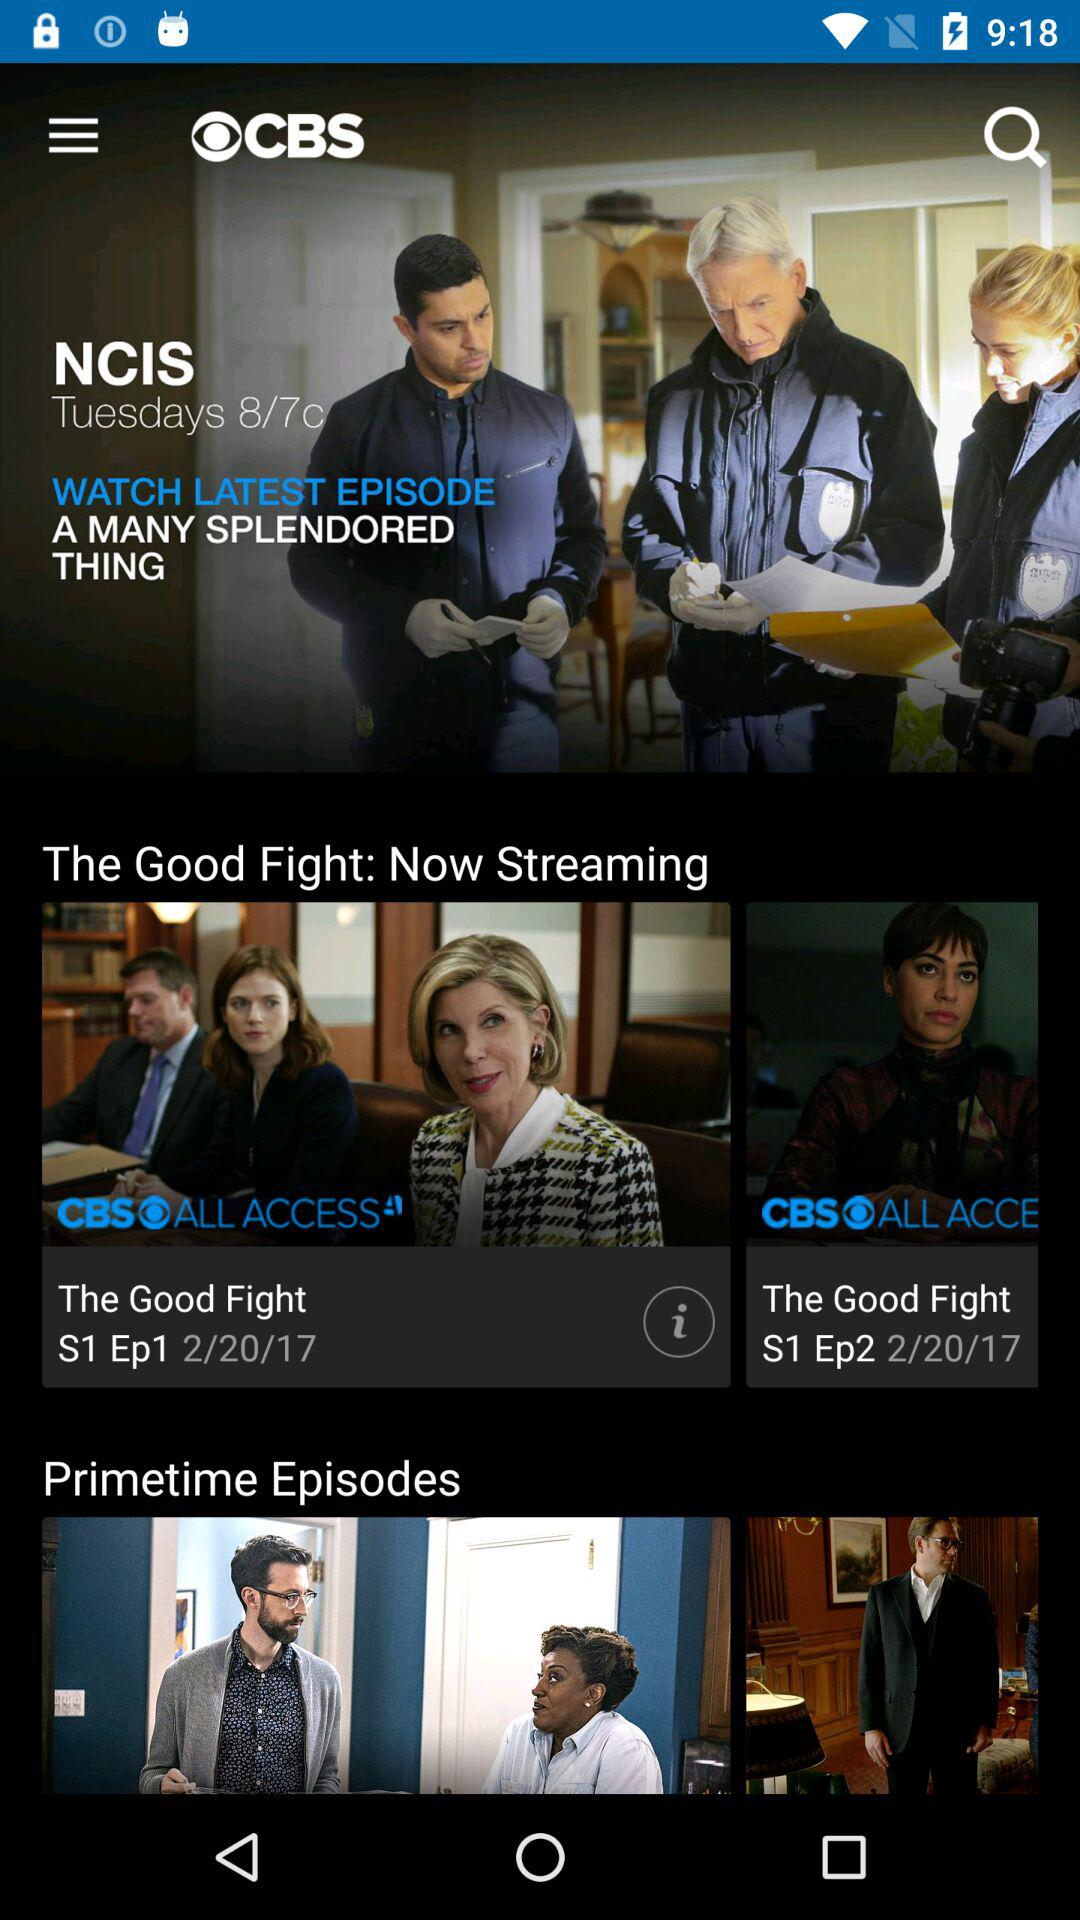How many days are there in the current month?
Answer the question using a single word or phrase. 28 